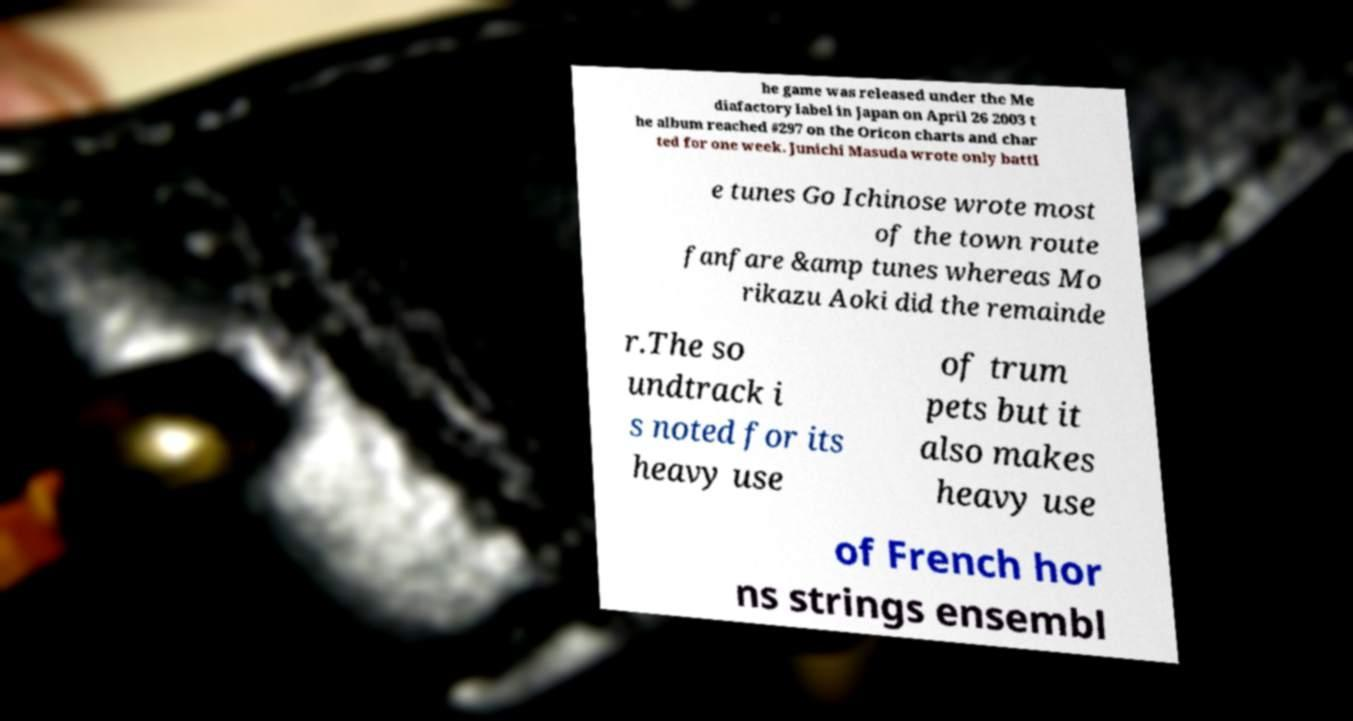Could you extract and type out the text from this image? he game was released under the Me diafactory label in Japan on April 26 2003 t he album reached #297 on the Oricon charts and char ted for one week. Junichi Masuda wrote only battl e tunes Go Ichinose wrote most of the town route fanfare &amp tunes whereas Mo rikazu Aoki did the remainde r.The so undtrack i s noted for its heavy use of trum pets but it also makes heavy use of French hor ns strings ensembl 